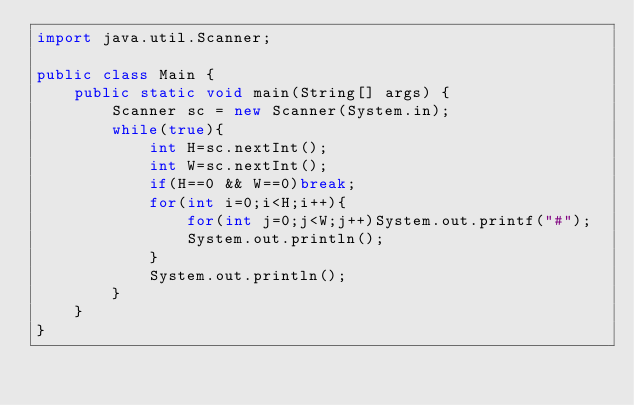Convert code to text. <code><loc_0><loc_0><loc_500><loc_500><_Java_>import java.util.Scanner;

public class Main {
    public static void main(String[] args) {
        Scanner sc = new Scanner(System.in);
        while(true){
            int H=sc.nextInt();
            int W=sc.nextInt();
            if(H==0 && W==0)break;
            for(int i=0;i<H;i++){
                for(int j=0;j<W;j++)System.out.printf("#");
                System.out.println();
            }
            System.out.println();
        }
    }
}
</code> 